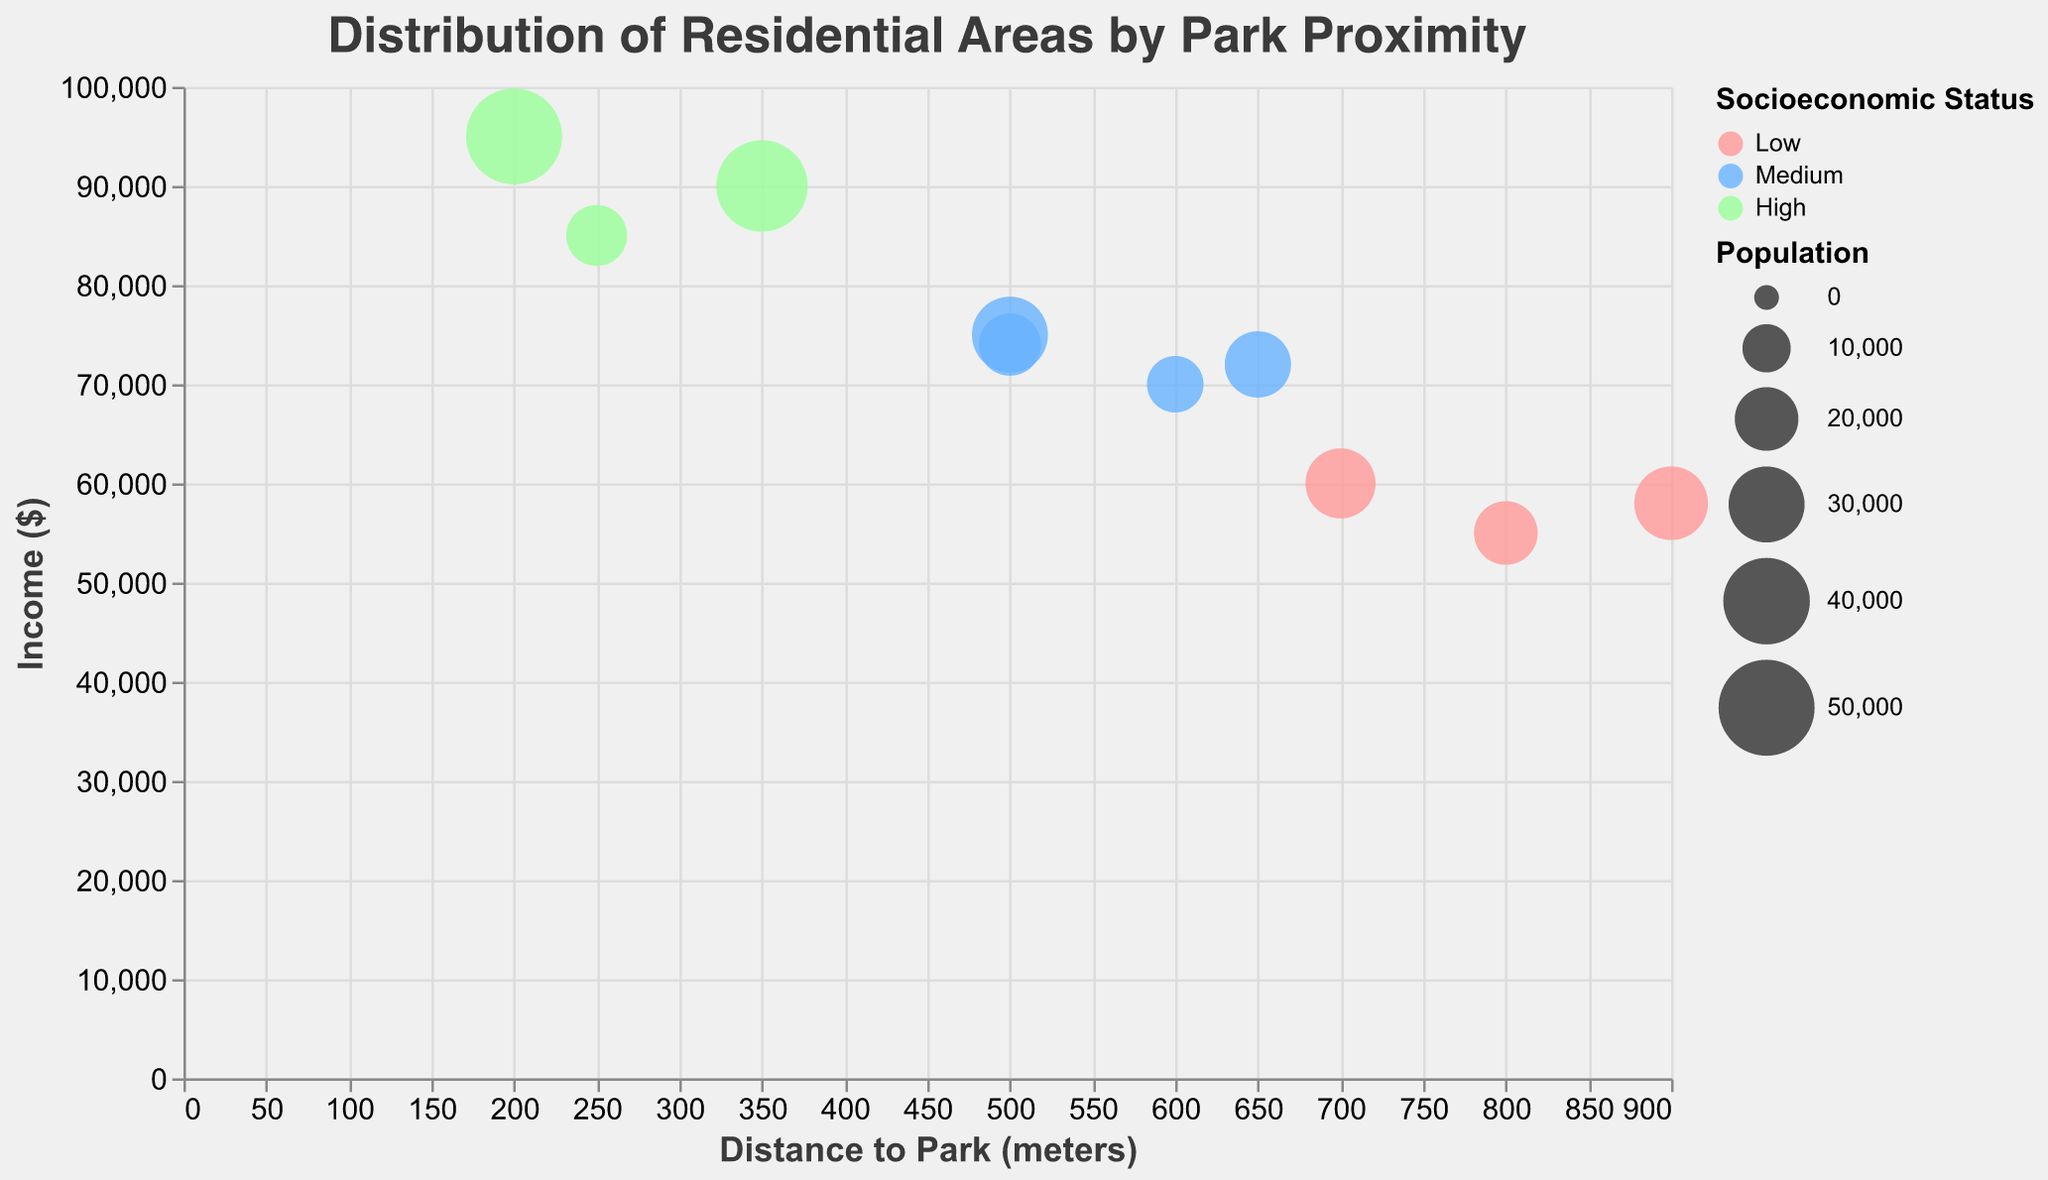What's the title of the chart? The title is located at the top of the chart.
Answer: Distribution of Residential Areas by Park Proximity How many residential areas have a high socioeconomic status? Look at the color used for "High" socioeconomic status and count the corresponding circles.
Answer: 3 Which area has the highest income? Observe the y-axis (Income) and identify the highest point where circles are plotted.
Answer: Central Park Area What is the average distance to the park for areas with a medium socioeconomic status? Identify circles colored for "Medium" status, note their distances, and calculate the average: (500 + 600 + 650 + 500)/4.
Answer: 562.5 meters Compare the income levels of "Van Cortlandt Park Zone" and "Forest Park Area". Which one is higher? Locate the two data points on the y-axis and compare their positions.
Answer: Forest Park Area What's the population size of "Marine Park Belt"? Refer to the size of the circle for "Marine Park Belt" as indicated in the legend.
Answer: 22,000 Which area is the furthest from a park? Look at the x-axis (Distance to Park) and identify the point with the highest value.
Answer: Pelham Bay Park Sector Is there a trend between income and distance to a park? Observe the general direction of the circles along the x (Distance to Park) and y (Income) axes.
Answer: No clear trend Which low socioeconomic status area is closest to a park? Look for the smallest distance on the x-axis among the circles colored for "Low" status.
Answer: Van Cortlandt Park Zone What is the income difference between the areas closest and furthest from the park? Identify the two areas (Central Park Area and Pelham Bay Park Sector) and subtract their incomes: 95,000 - 58,000.
Answer: 37,000 